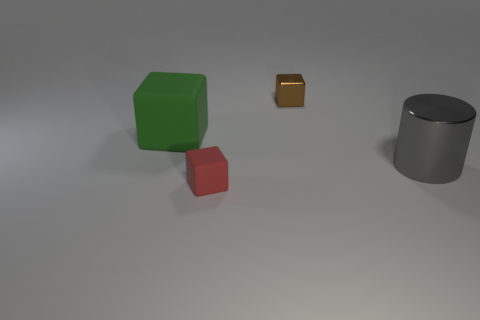Add 2 small metallic blocks. How many objects exist? 6 Subtract all blocks. How many objects are left? 1 Add 3 small rubber blocks. How many small rubber blocks exist? 4 Subtract 0 purple spheres. How many objects are left? 4 Subtract all tiny cyan matte cubes. Subtract all brown metallic objects. How many objects are left? 3 Add 4 green objects. How many green objects are left? 5 